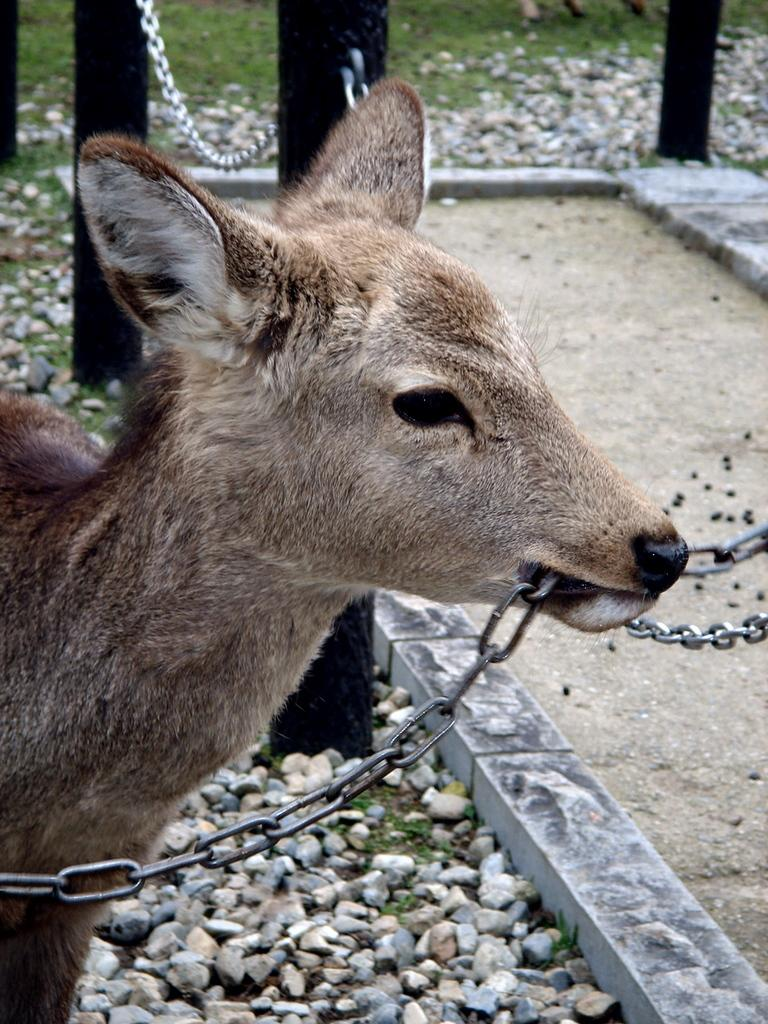What animal is present in the image? There is a deer in the image. What is the deer doing in the image? The deer has a chain in its mouth. What can be seen in the background of the image? There are stones, rods, a chain, and grass in the background of the image. What type of surface is visible in the image? There is a walkway in the image. What type of lace is being used to decorate the feast in the image? There is no feast or lace present in the image; it features a deer with a chain in its mouth and a background with stones, rods, a chain, and grass. 